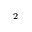<formula> <loc_0><loc_0><loc_500><loc_500>^ { 2 }</formula> 